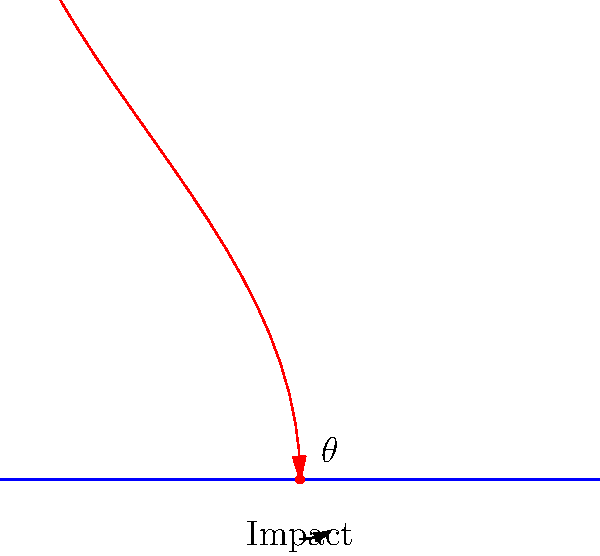A projectile is fired towards a soft tissue surface. Based on the diagram, determine the angle of impact ($\theta$) and estimate the velocity ($v$) of the projectile at the moment of impact, given that the initial velocity was 100 m/s and the projectile traveled 80 meters horizontally before impact. To solve this problem, we'll follow these steps:

1. Determine the angle of impact ($\theta$):
   The angle of impact is the angle between the trajectory of the projectile at the point of impact and the surface. From the diagram, we can see that $\theta = 90° - 60° = 30°$.

2. Estimate the velocity at impact:
   We'll use the projectile motion equations, assuming no air resistance:

   a) Time of flight:
      $x = v_0 \cos(\alpha) t$
      $80 = 100 \cos(60°) t$
      $t = \frac{80}{100 \cos(60°)} = 1.6$ seconds

   b) Vertical velocity at impact:
      $v_y = v_0 \sin(\alpha) - gt$
      $v_y = 100 \sin(60°) - 9.8 * 1.6 = 70.4$ m/s

   c) Horizontal velocity (constant):
      $v_x = v_0 \cos(\alpha) = 100 \cos(60°) = 50$ m/s

   d) Resultant velocity at impact:
      $v = \sqrt{v_x^2 + v_y^2} = \sqrt{50^2 + 70.4^2} = 86.4$ m/s

Therefore, the angle of impact is 30°, and the estimated velocity at impact is 86.4 m/s.
Answer: $\theta = 30°$, $v \approx 86.4$ m/s 